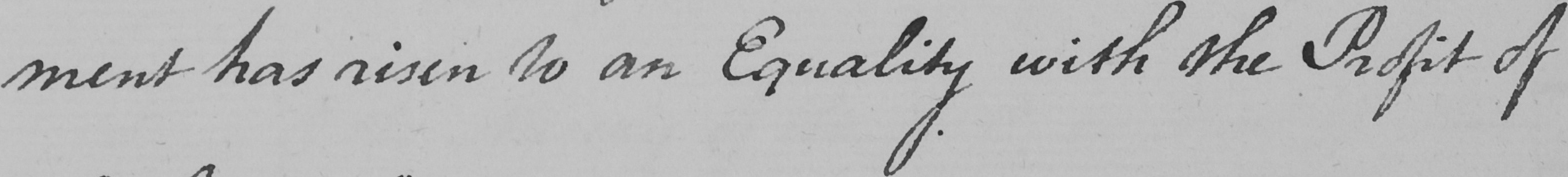Transcribe the text shown in this historical manuscript line. -ment has risen to an Equality with the Profit of 